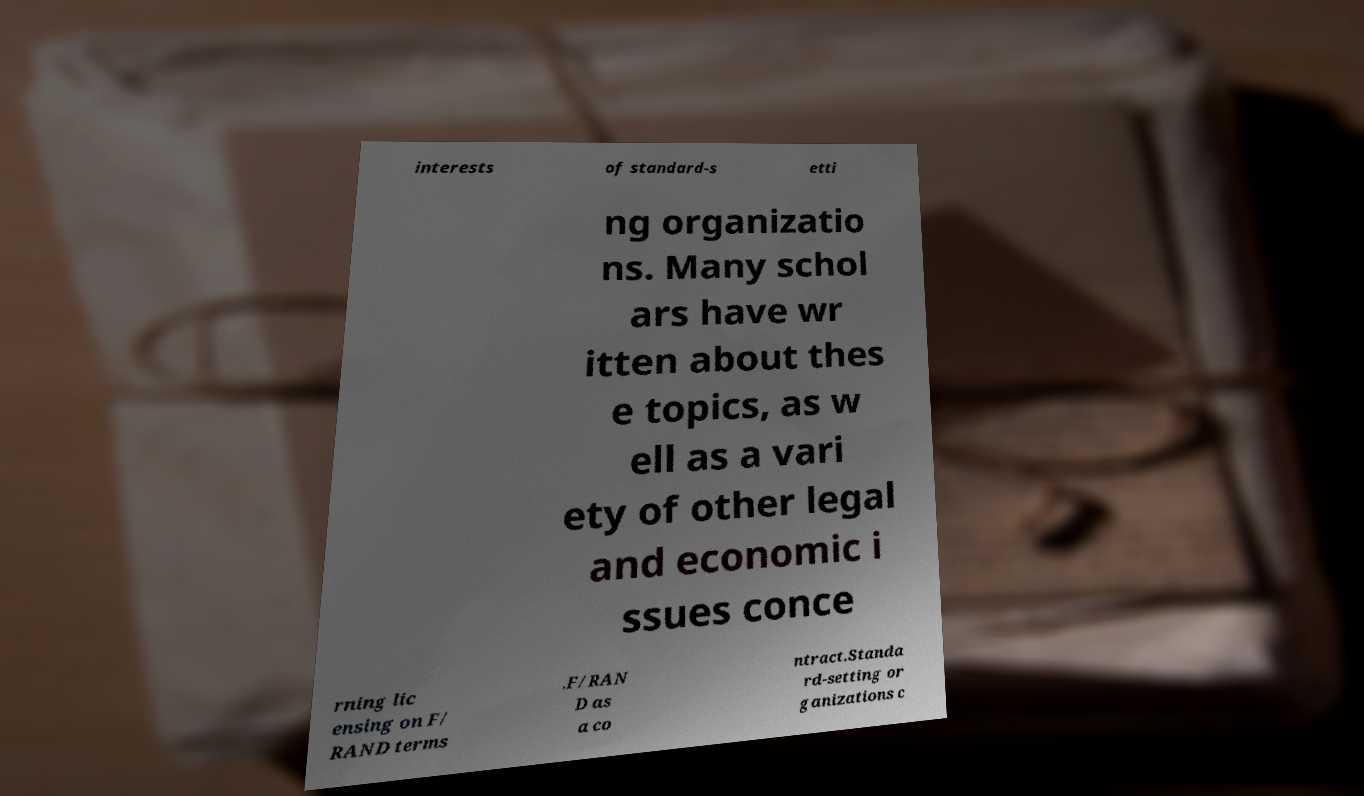What messages or text are displayed in this image? I need them in a readable, typed format. interests of standard-s etti ng organizatio ns. Many schol ars have wr itten about thes e topics, as w ell as a vari ety of other legal and economic i ssues conce rning lic ensing on F/ RAND terms .F/RAN D as a co ntract.Standa rd-setting or ganizations c 